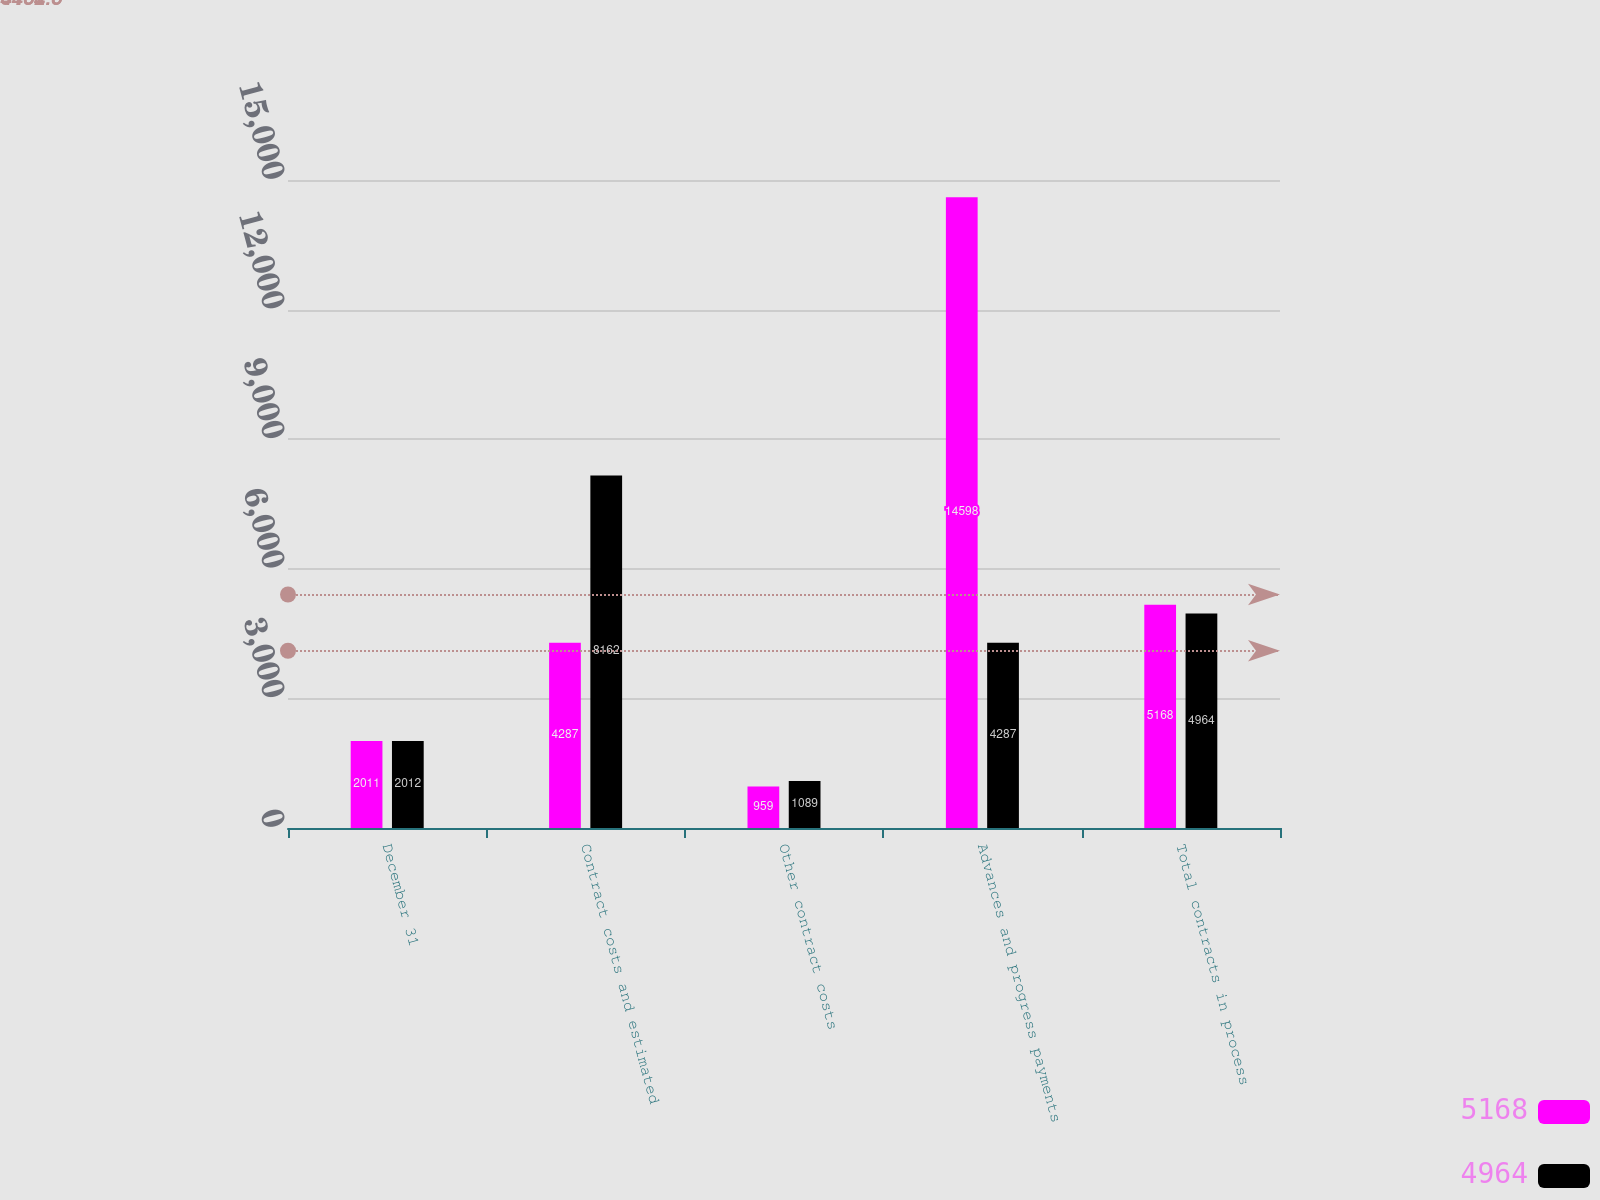Convert chart. <chart><loc_0><loc_0><loc_500><loc_500><stacked_bar_chart><ecel><fcel>December 31<fcel>Contract costs and estimated<fcel>Other contract costs<fcel>Advances and progress payments<fcel>Total contracts in process<nl><fcel>5168<fcel>2011<fcel>4287<fcel>959<fcel>14598<fcel>5168<nl><fcel>4964<fcel>2012<fcel>8162<fcel>1089<fcel>4287<fcel>4964<nl></chart> 